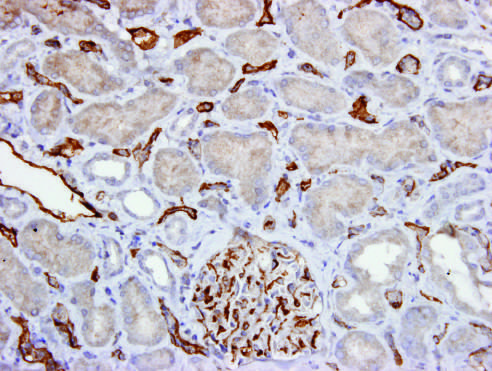what stain shows c4d deposition in peritubular capillaries and a glomerulus?
Answer the question using a single word or phrase. Immunoperoxidase stain 